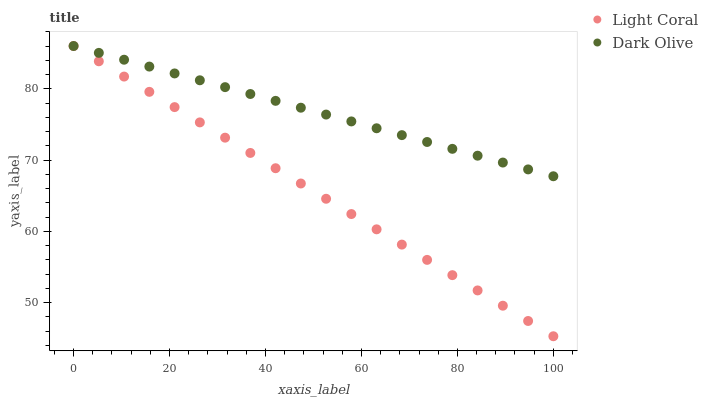Does Light Coral have the minimum area under the curve?
Answer yes or no. Yes. Does Dark Olive have the maximum area under the curve?
Answer yes or no. Yes. Does Dark Olive have the minimum area under the curve?
Answer yes or no. No. Is Dark Olive the smoothest?
Answer yes or no. Yes. Is Light Coral the roughest?
Answer yes or no. Yes. Is Dark Olive the roughest?
Answer yes or no. No. Does Light Coral have the lowest value?
Answer yes or no. Yes. Does Dark Olive have the lowest value?
Answer yes or no. No. Does Dark Olive have the highest value?
Answer yes or no. Yes. Does Dark Olive intersect Light Coral?
Answer yes or no. Yes. Is Dark Olive less than Light Coral?
Answer yes or no. No. Is Dark Olive greater than Light Coral?
Answer yes or no. No. 